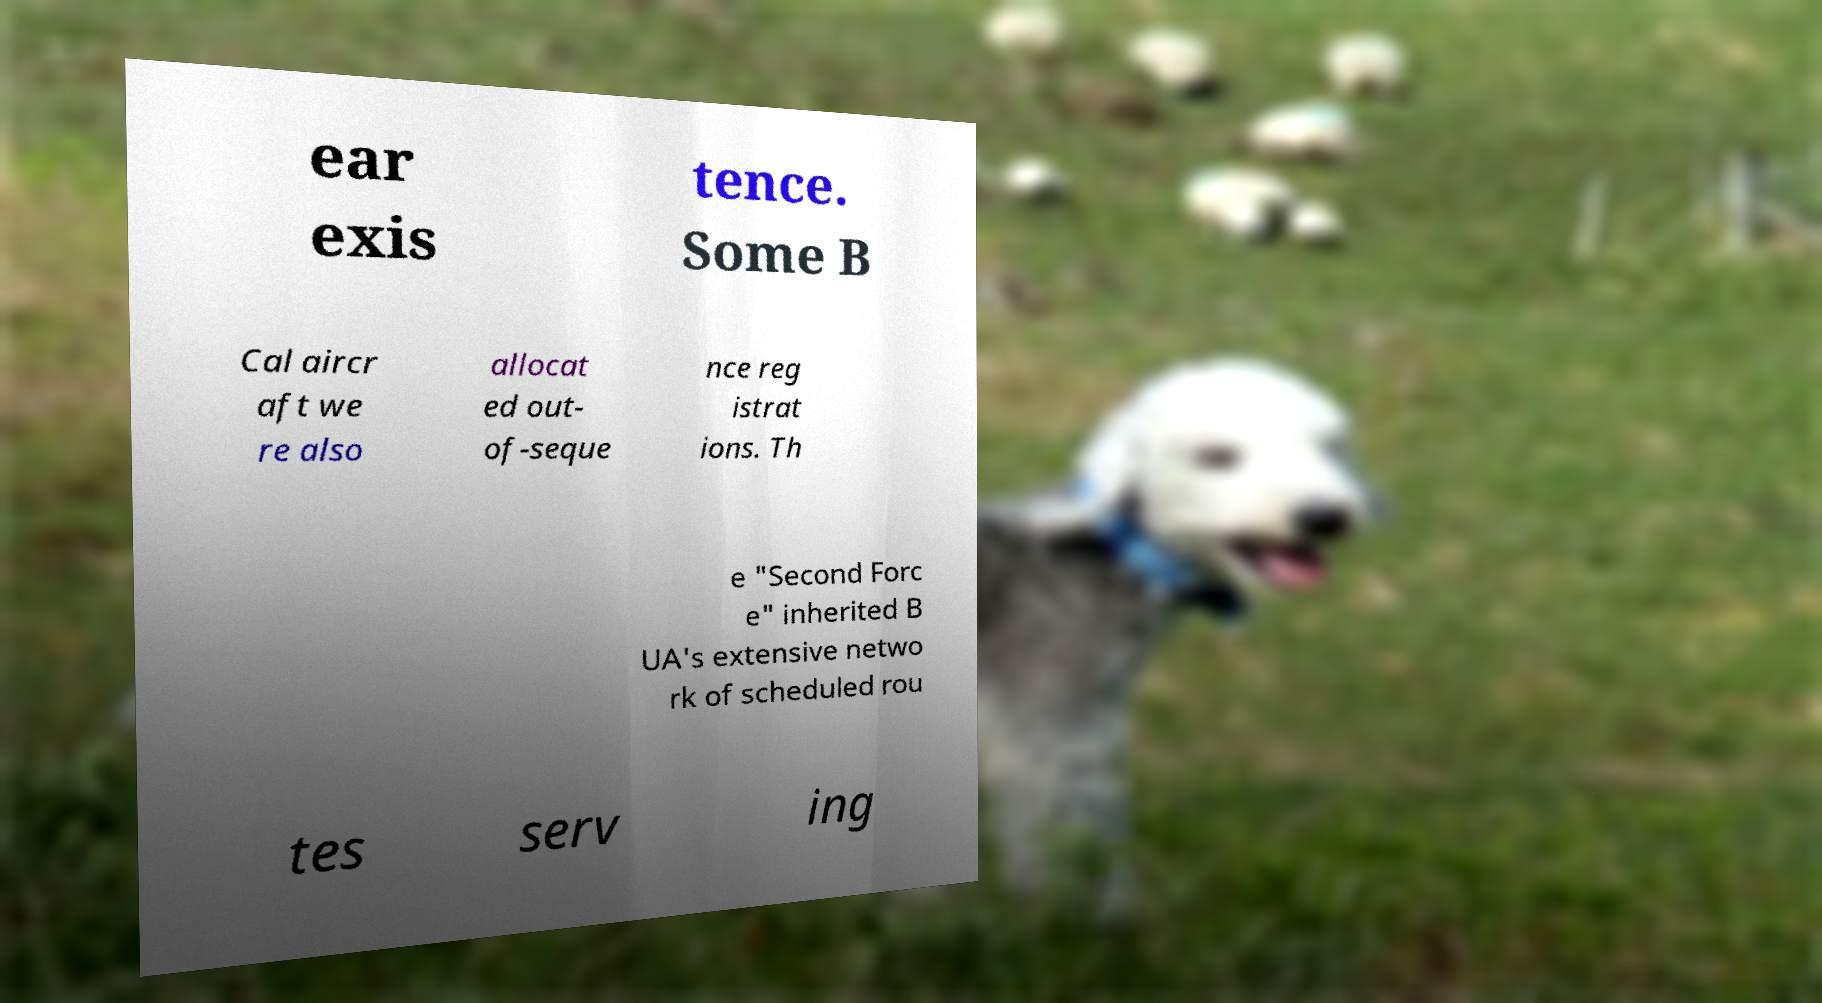I need the written content from this picture converted into text. Can you do that? ear exis tence. Some B Cal aircr aft we re also allocat ed out- of-seque nce reg istrat ions. Th e "Second Forc e" inherited B UA's extensive netwo rk of scheduled rou tes serv ing 